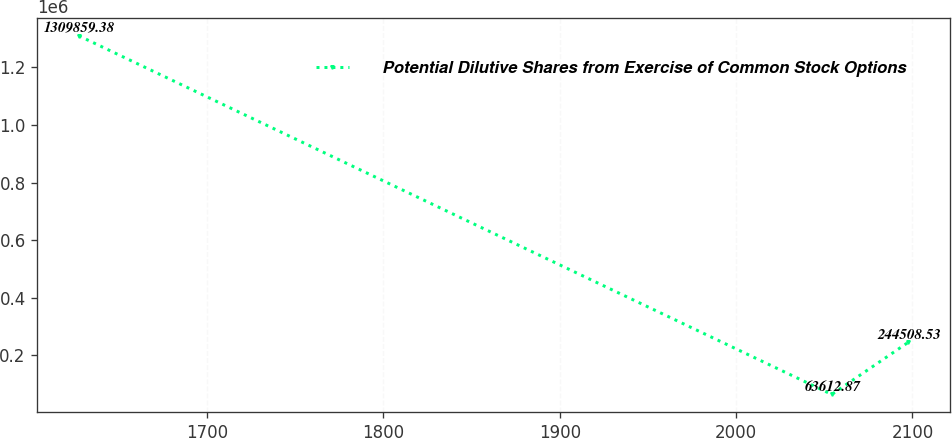<chart> <loc_0><loc_0><loc_500><loc_500><line_chart><ecel><fcel>Potential Dilutive Shares from Exercise of Common Stock Options<nl><fcel>1627.29<fcel>1.30986e+06<nl><fcel>2054.27<fcel>63612.9<nl><fcel>2097.61<fcel>244509<nl></chart> 